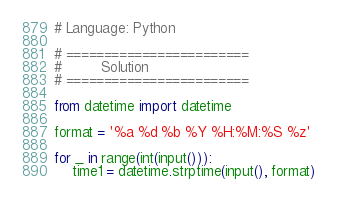<code> <loc_0><loc_0><loc_500><loc_500><_Python_># Language: Python

# ========================
#         Solution
# ========================

from datetime import datetime

format = '%a %d %b %Y %H:%M:%S %z'

for _ in range(int(input())):
    time1 = datetime.strptime(input(), format)</code> 